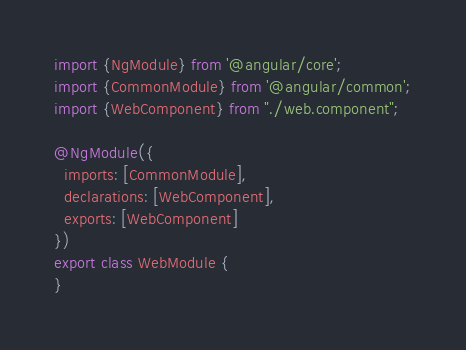<code> <loc_0><loc_0><loc_500><loc_500><_TypeScript_>import {NgModule} from '@angular/core';
import {CommonModule} from '@angular/common';
import {WebComponent} from "./web.component";

@NgModule({
  imports: [CommonModule],
  declarations: [WebComponent],
  exports: [WebComponent]
})
export class WebModule {
}
</code> 